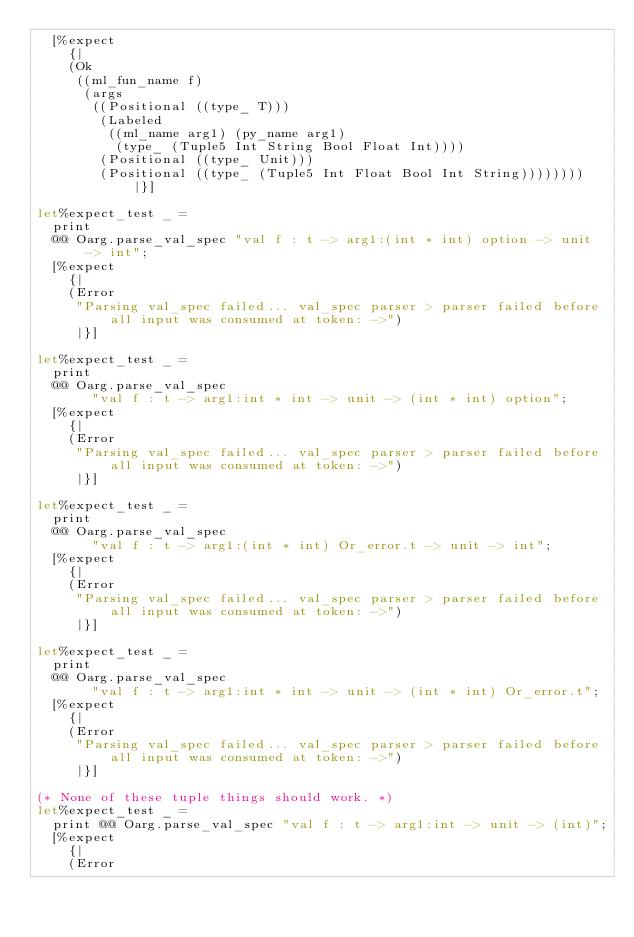<code> <loc_0><loc_0><loc_500><loc_500><_OCaml_>  [%expect
    {|
    (Ok
     ((ml_fun_name f)
      (args
       ((Positional ((type_ T)))
        (Labeled
         ((ml_name arg1) (py_name arg1)
          (type_ (Tuple5 Int String Bool Float Int))))
        (Positional ((type_ Unit)))
        (Positional ((type_ (Tuple5 Int Float Bool Int String)))))))) |}]

let%expect_test _ =
  print
  @@ Oarg.parse_val_spec "val f : t -> arg1:(int * int) option -> unit -> int";
  [%expect
    {|
    (Error
     "Parsing val_spec failed... val_spec parser > parser failed before all input was consumed at token: ->")
     |}]

let%expect_test _ =
  print
  @@ Oarg.parse_val_spec
       "val f : t -> arg1:int * int -> unit -> (int * int) option";
  [%expect
    {|
    (Error
     "Parsing val_spec failed... val_spec parser > parser failed before all input was consumed at token: ->")
     |}]

let%expect_test _ =
  print
  @@ Oarg.parse_val_spec
       "val f : t -> arg1:(int * int) Or_error.t -> unit -> int";
  [%expect
    {|
    (Error
     "Parsing val_spec failed... val_spec parser > parser failed before all input was consumed at token: ->")
     |}]

let%expect_test _ =
  print
  @@ Oarg.parse_val_spec
       "val f : t -> arg1:int * int -> unit -> (int * int) Or_error.t";
  [%expect
    {|
    (Error
     "Parsing val_spec failed... val_spec parser > parser failed before all input was consumed at token: ->")
     |}]

(* None of these tuple things should work. *)
let%expect_test _ =
  print @@ Oarg.parse_val_spec "val f : t -> arg1:int -> unit -> (int)";
  [%expect
    {|
    (Error</code> 